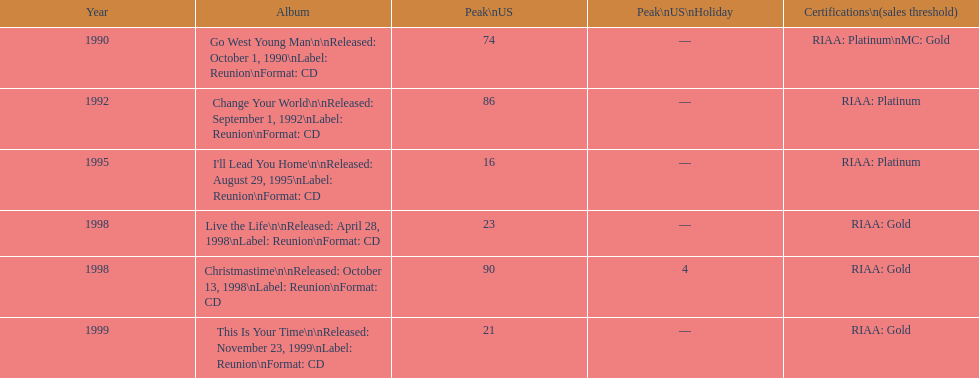How many tracks are there from 1998 in the list? 2. 